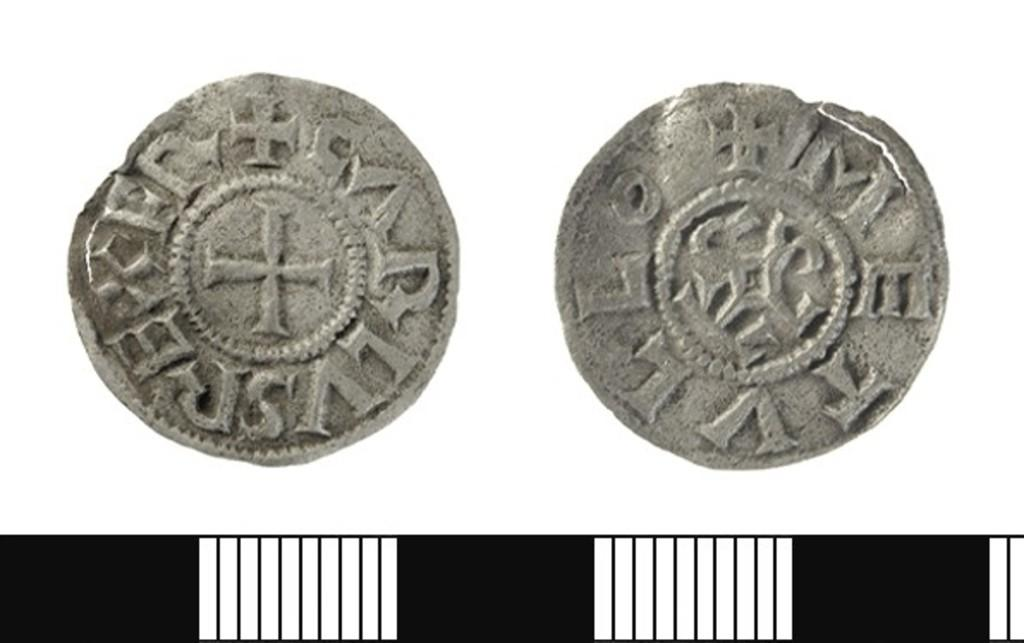<image>
Relay a brief, clear account of the picture shown. Coins have letters on them including an E and T. 